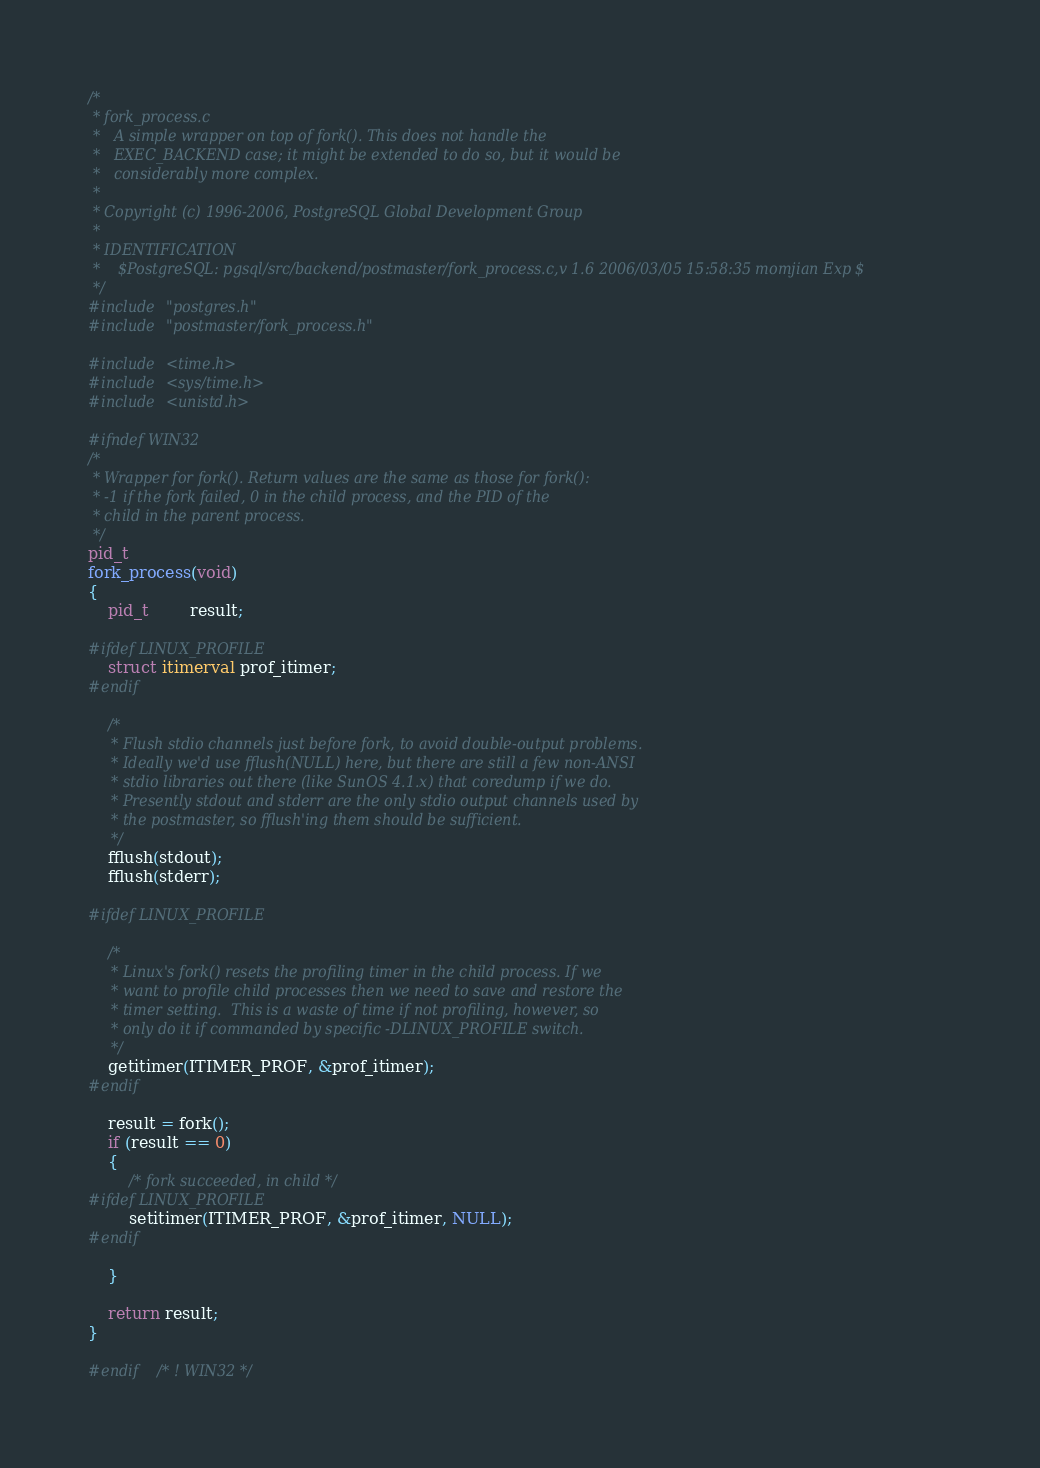Convert code to text. <code><loc_0><loc_0><loc_500><loc_500><_C_>/*
 * fork_process.c
 *	 A simple wrapper on top of fork(). This does not handle the
 *	 EXEC_BACKEND case; it might be extended to do so, but it would be
 *	 considerably more complex.
 *
 * Copyright (c) 1996-2006, PostgreSQL Global Development Group
 *
 * IDENTIFICATION
 *	  $PostgreSQL: pgsql/src/backend/postmaster/fork_process.c,v 1.6 2006/03/05 15:58:35 momjian Exp $
 */
#include "postgres.h"
#include "postmaster/fork_process.h"

#include <time.h>
#include <sys/time.h>
#include <unistd.h>

#ifndef WIN32
/*
 * Wrapper for fork(). Return values are the same as those for fork():
 * -1 if the fork failed, 0 in the child process, and the PID of the
 * child in the parent process.
 */
pid_t
fork_process(void)
{
	pid_t		result;

#ifdef LINUX_PROFILE
	struct itimerval prof_itimer;
#endif

	/*
	 * Flush stdio channels just before fork, to avoid double-output problems.
	 * Ideally we'd use fflush(NULL) here, but there are still a few non-ANSI
	 * stdio libraries out there (like SunOS 4.1.x) that coredump if we do.
	 * Presently stdout and stderr are the only stdio output channels used by
	 * the postmaster, so fflush'ing them should be sufficient.
	 */
	fflush(stdout);
	fflush(stderr);

#ifdef LINUX_PROFILE

	/*
	 * Linux's fork() resets the profiling timer in the child process. If we
	 * want to profile child processes then we need to save and restore the
	 * timer setting.  This is a waste of time if not profiling, however, so
	 * only do it if commanded by specific -DLINUX_PROFILE switch.
	 */
	getitimer(ITIMER_PROF, &prof_itimer);
#endif

	result = fork();
	if (result == 0)
	{
		/* fork succeeded, in child */
#ifdef LINUX_PROFILE
		setitimer(ITIMER_PROF, &prof_itimer, NULL);
#endif

	}

	return result;
}

#endif   /* ! WIN32 */
</code> 